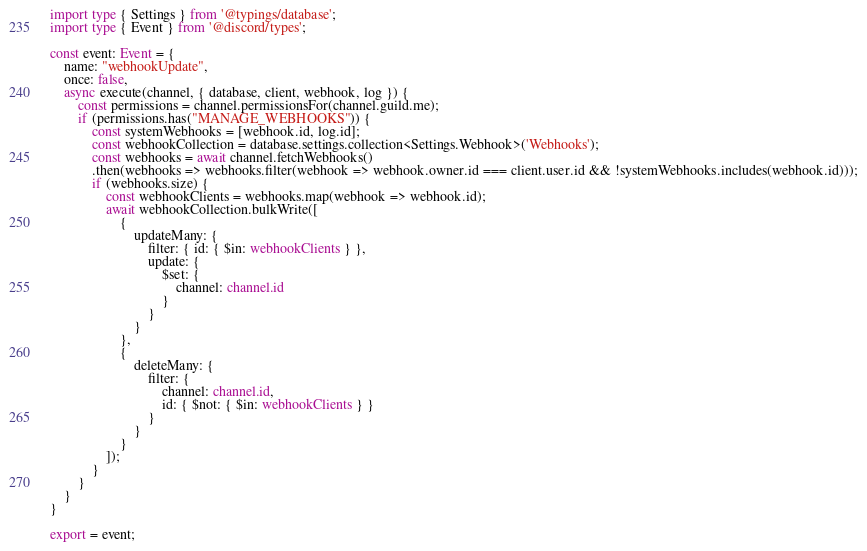Convert code to text. <code><loc_0><loc_0><loc_500><loc_500><_TypeScript_>import type { Settings } from '@typings/database';
import type { Event } from '@discord/types';

const event: Event = {
    name: "webhookUpdate",
    once: false,
    async execute(channel, { database, client, webhook, log }) {
        const permissions = channel.permissionsFor(channel.guild.me);
        if (permissions.has("MANAGE_WEBHOOKS")) {
            const systemWebhooks = [webhook.id, log.id];
            const webhookCollection = database.settings.collection<Settings.Webhook>('Webhooks');
            const webhooks = await channel.fetchWebhooks()
            .then(webhooks => webhooks.filter(webhook => webhook.owner.id === client.user.id && !systemWebhooks.includes(webhook.id)));
            if (webhooks.size) {
                const webhookClients = webhooks.map(webhook => webhook.id);
                await webhookCollection.bulkWrite([
                    {
                        updateMany: {
                            filter: { id: { $in: webhookClients } },
                            update: {
                                $set: {
                                    channel: channel.id
                                }
                            }
                        }
                    },
                    {
                        deleteMany: {
                            filter: { 
                                channel: channel.id,
                                id: { $not: { $in: webhookClients } } 
                            }
                        }
                    }
                ]);
            }
        }
    }
}

export = event;</code> 